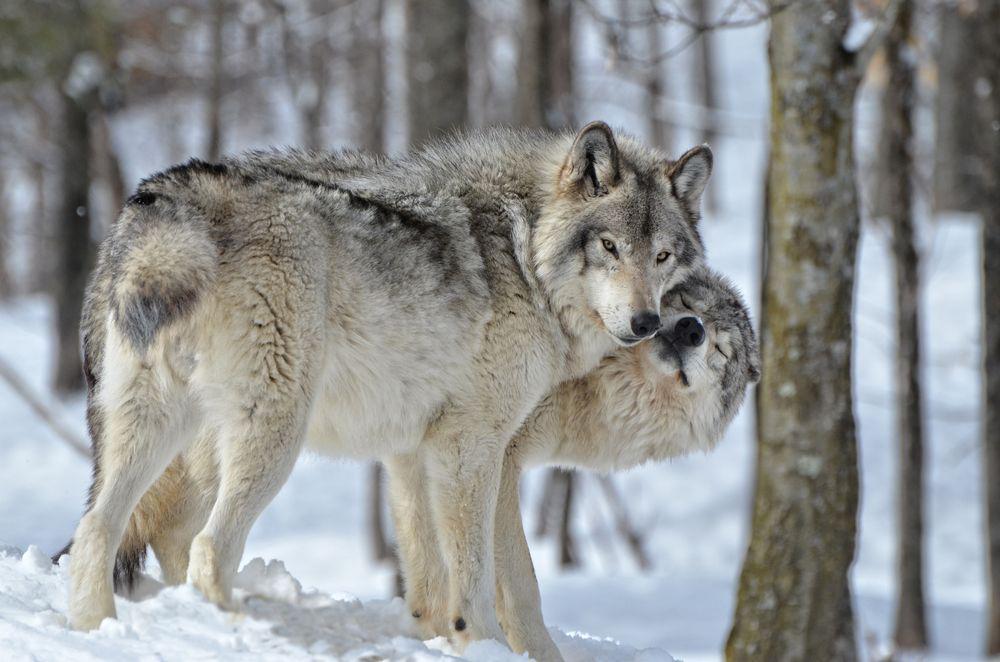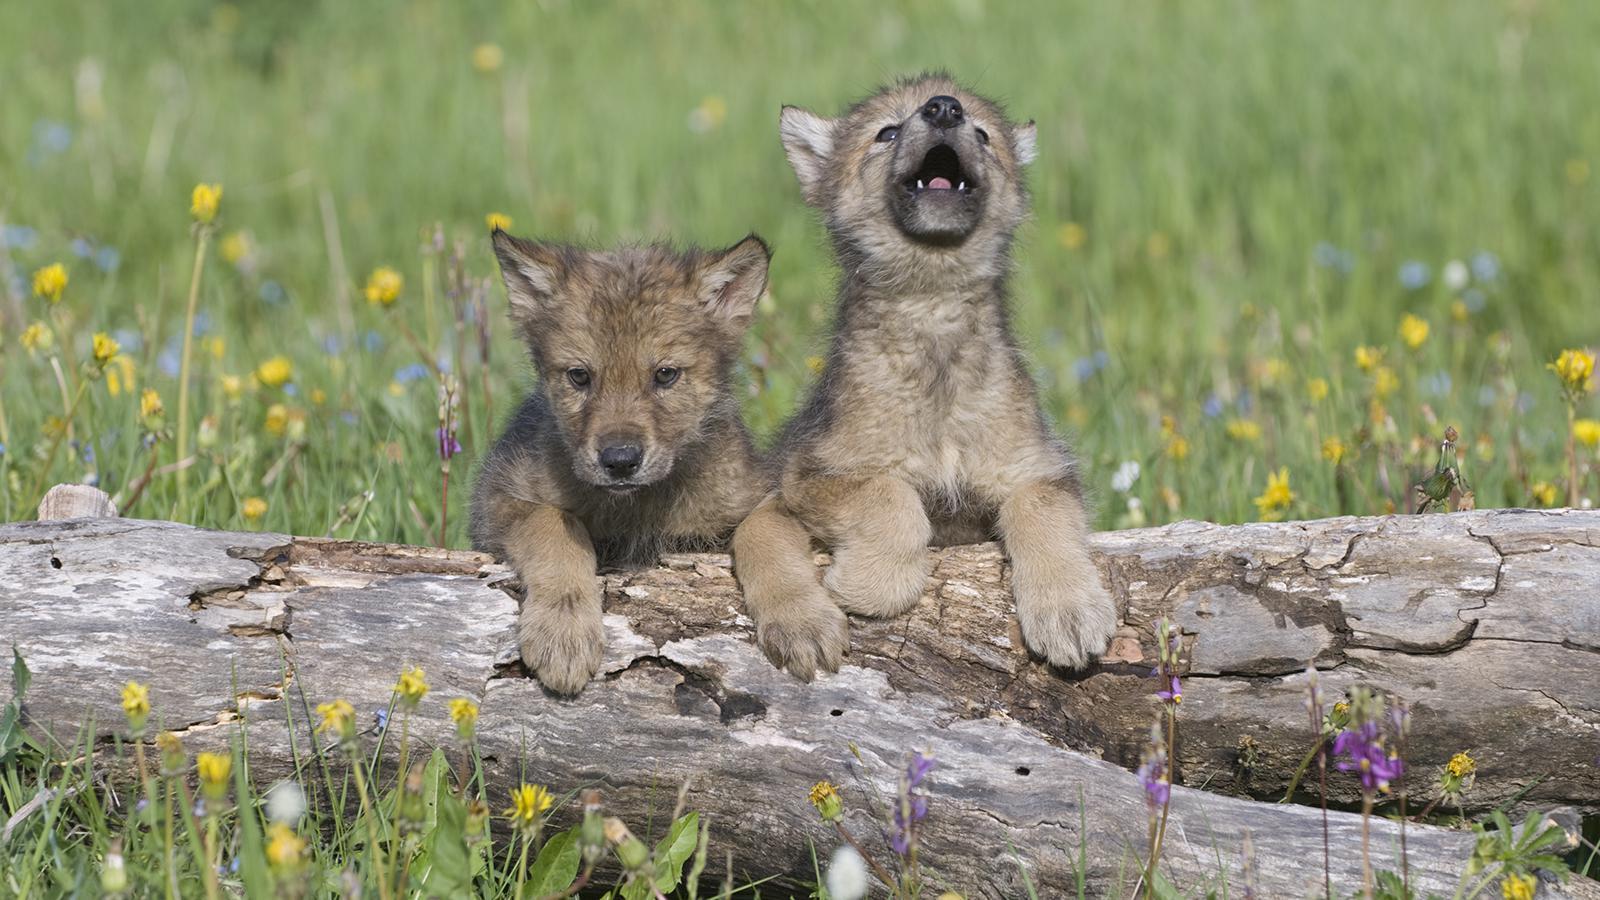The first image is the image on the left, the second image is the image on the right. For the images displayed, is the sentence "At least one dog has its front paws standing in a pool of water surrounded by rocks and green grass." factually correct? Answer yes or no. No. The first image is the image on the left, the second image is the image on the right. Analyze the images presented: Is the assertion "There is exactly four wolves in the right image." valid? Answer yes or no. No. 